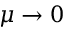Convert formula to latex. <formula><loc_0><loc_0><loc_500><loc_500>\mu \to 0</formula> 